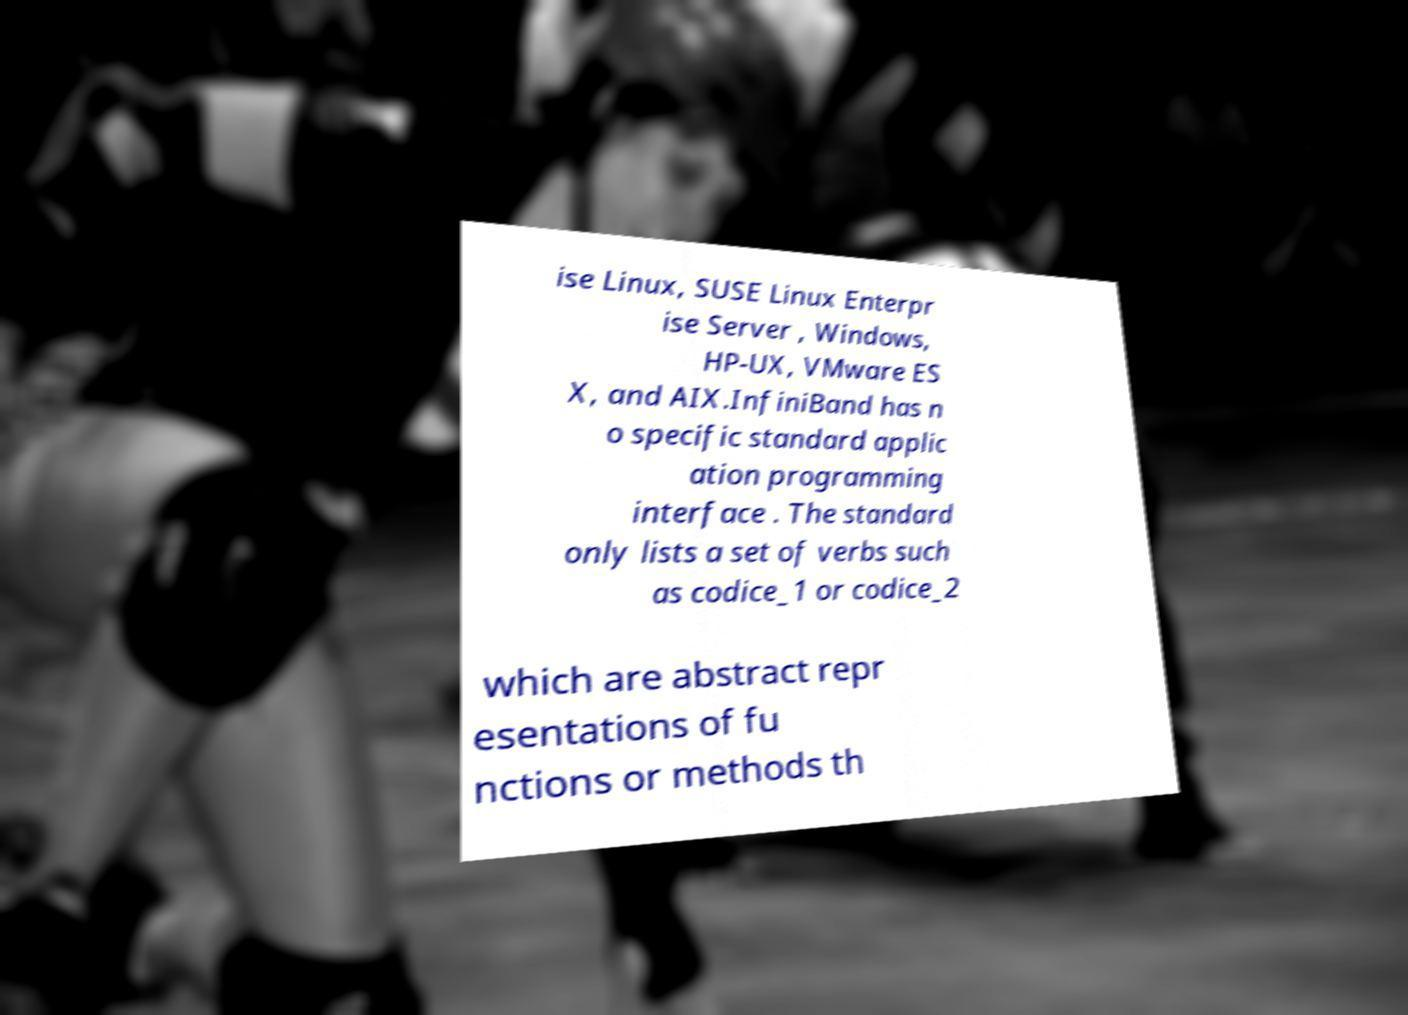Could you extract and type out the text from this image? ise Linux, SUSE Linux Enterpr ise Server , Windows, HP-UX, VMware ES X, and AIX.InfiniBand has n o specific standard applic ation programming interface . The standard only lists a set of verbs such as codice_1 or codice_2 which are abstract repr esentations of fu nctions or methods th 